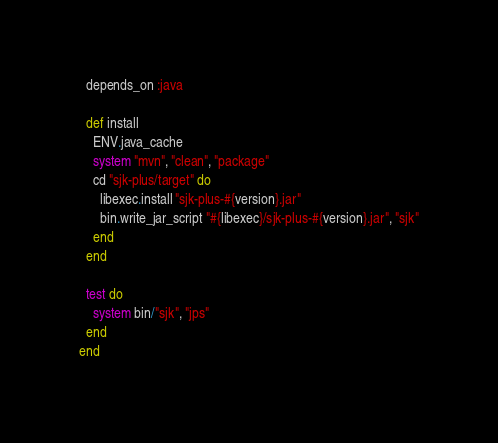Convert code to text. <code><loc_0><loc_0><loc_500><loc_500><_Ruby_>  depends_on :java

  def install
    ENV.java_cache
    system "mvn", "clean", "package"
    cd "sjk-plus/target" do
      libexec.install "sjk-plus-#{version}.jar"
      bin.write_jar_script "#{libexec}/sjk-plus-#{version}.jar", "sjk"
    end
  end

  test do
    system bin/"sjk", "jps"
  end
end
</code> 